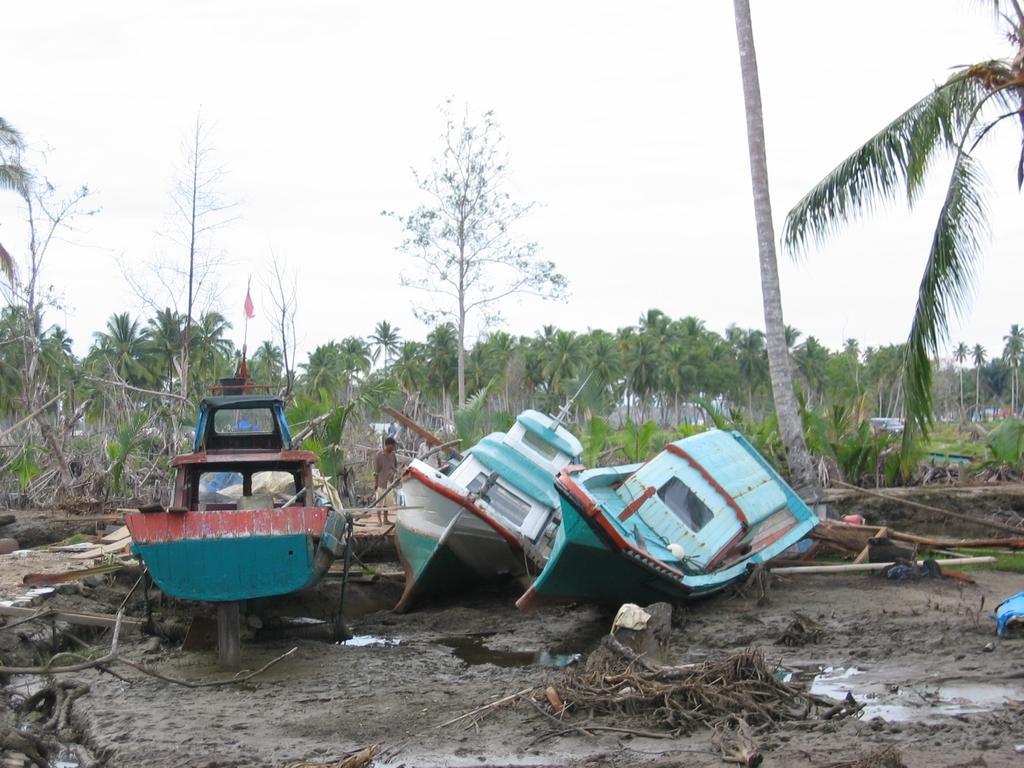Can you describe this image briefly? In this image we can see some boats on the land. We can also see some water, mud, bark of the trees and a person standing beside the boats. On the backside we can see a group of trees and the sky which looks cloudy. 